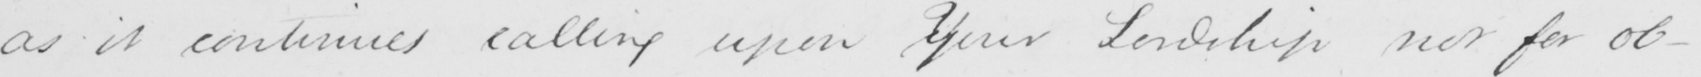Please transcribe the handwritten text in this image. as it continues calling upon yYour Lordship nor for ob- 